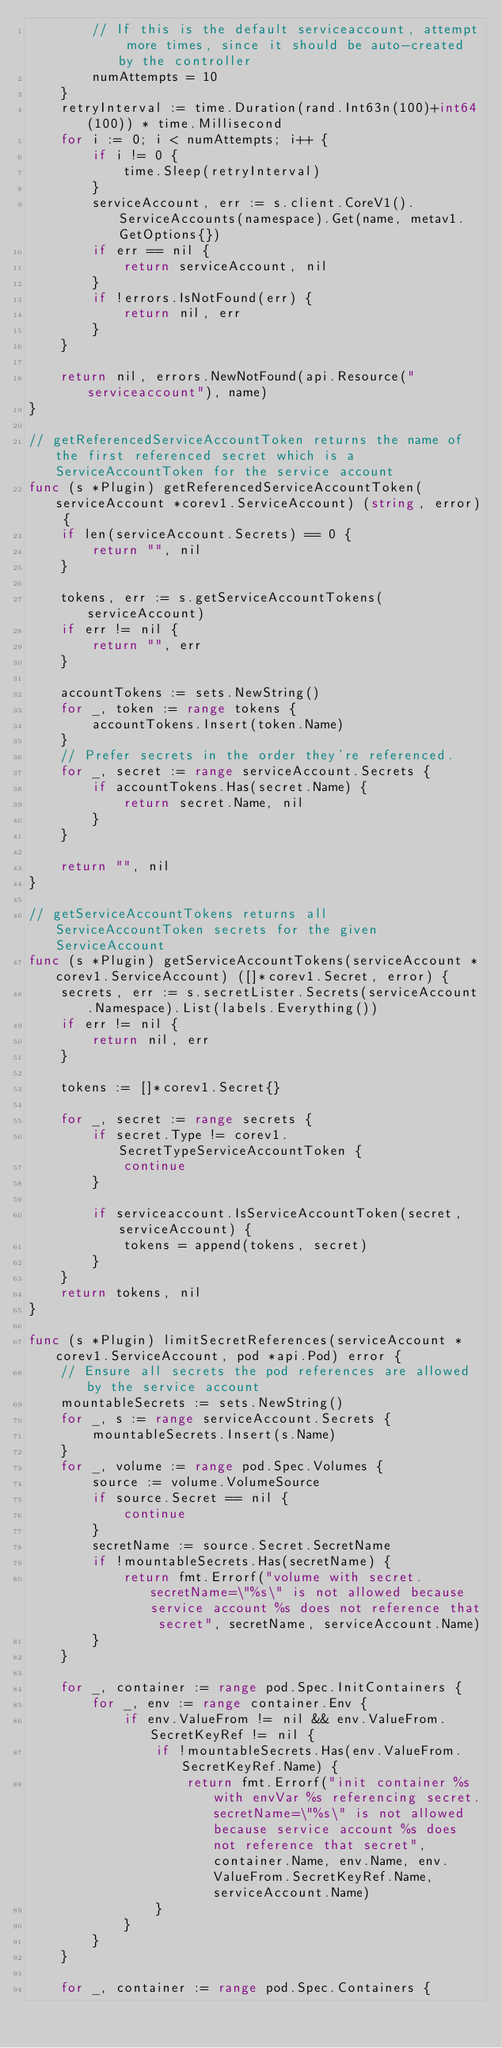<code> <loc_0><loc_0><loc_500><loc_500><_Go_>		// If this is the default serviceaccount, attempt more times, since it should be auto-created by the controller
		numAttempts = 10
	}
	retryInterval := time.Duration(rand.Int63n(100)+int64(100)) * time.Millisecond
	for i := 0; i < numAttempts; i++ {
		if i != 0 {
			time.Sleep(retryInterval)
		}
		serviceAccount, err := s.client.CoreV1().ServiceAccounts(namespace).Get(name, metav1.GetOptions{})
		if err == nil {
			return serviceAccount, nil
		}
		if !errors.IsNotFound(err) {
			return nil, err
		}
	}

	return nil, errors.NewNotFound(api.Resource("serviceaccount"), name)
}

// getReferencedServiceAccountToken returns the name of the first referenced secret which is a ServiceAccountToken for the service account
func (s *Plugin) getReferencedServiceAccountToken(serviceAccount *corev1.ServiceAccount) (string, error) {
	if len(serviceAccount.Secrets) == 0 {
		return "", nil
	}

	tokens, err := s.getServiceAccountTokens(serviceAccount)
	if err != nil {
		return "", err
	}

	accountTokens := sets.NewString()
	for _, token := range tokens {
		accountTokens.Insert(token.Name)
	}
	// Prefer secrets in the order they're referenced.
	for _, secret := range serviceAccount.Secrets {
		if accountTokens.Has(secret.Name) {
			return secret.Name, nil
		}
	}

	return "", nil
}

// getServiceAccountTokens returns all ServiceAccountToken secrets for the given ServiceAccount
func (s *Plugin) getServiceAccountTokens(serviceAccount *corev1.ServiceAccount) ([]*corev1.Secret, error) {
	secrets, err := s.secretLister.Secrets(serviceAccount.Namespace).List(labels.Everything())
	if err != nil {
		return nil, err
	}

	tokens := []*corev1.Secret{}

	for _, secret := range secrets {
		if secret.Type != corev1.SecretTypeServiceAccountToken {
			continue
		}

		if serviceaccount.IsServiceAccountToken(secret, serviceAccount) {
			tokens = append(tokens, secret)
		}
	}
	return tokens, nil
}

func (s *Plugin) limitSecretReferences(serviceAccount *corev1.ServiceAccount, pod *api.Pod) error {
	// Ensure all secrets the pod references are allowed by the service account
	mountableSecrets := sets.NewString()
	for _, s := range serviceAccount.Secrets {
		mountableSecrets.Insert(s.Name)
	}
	for _, volume := range pod.Spec.Volumes {
		source := volume.VolumeSource
		if source.Secret == nil {
			continue
		}
		secretName := source.Secret.SecretName
		if !mountableSecrets.Has(secretName) {
			return fmt.Errorf("volume with secret.secretName=\"%s\" is not allowed because service account %s does not reference that secret", secretName, serviceAccount.Name)
		}
	}

	for _, container := range pod.Spec.InitContainers {
		for _, env := range container.Env {
			if env.ValueFrom != nil && env.ValueFrom.SecretKeyRef != nil {
				if !mountableSecrets.Has(env.ValueFrom.SecretKeyRef.Name) {
					return fmt.Errorf("init container %s with envVar %s referencing secret.secretName=\"%s\" is not allowed because service account %s does not reference that secret", container.Name, env.Name, env.ValueFrom.SecretKeyRef.Name, serviceAccount.Name)
				}
			}
		}
	}

	for _, container := range pod.Spec.Containers {</code> 